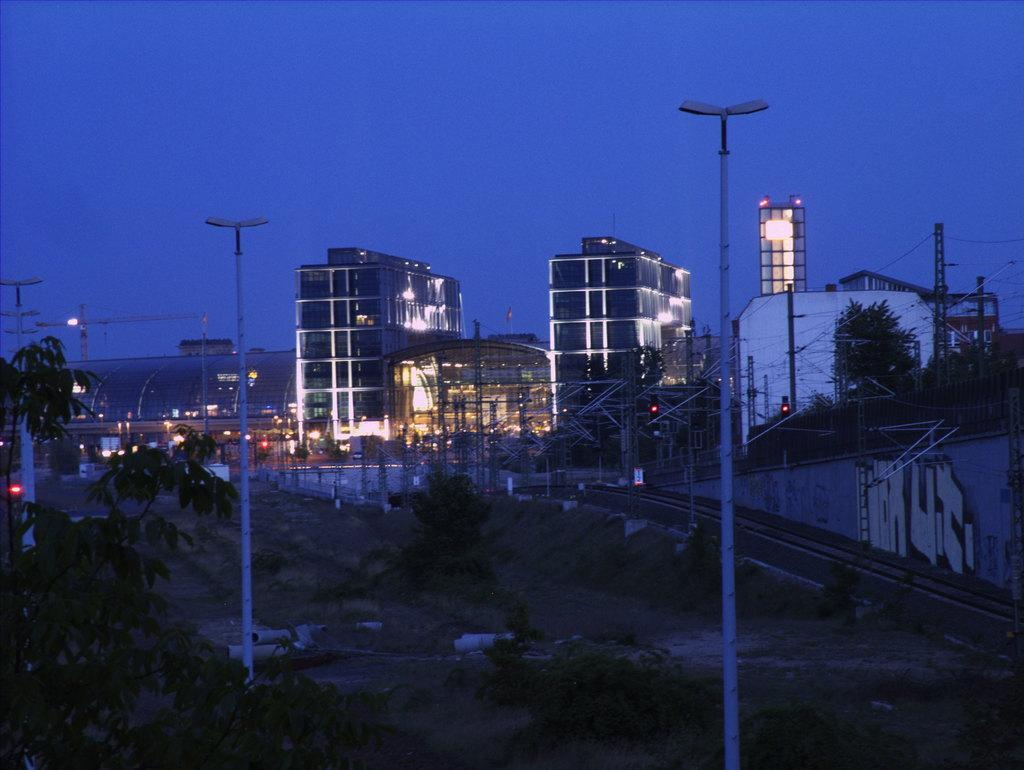What type of structures can be seen in the image? There are buildings and sheds in the image. What is located at the bottom of the image? A: Trees are present at the bottom of the image. What other objects can be seen in the image besides buildings and sheds? Poles and wires are visible in the image. What is on the right side of the image? There is a wall on the right side of the image. What can be seen in the background of the image? The sky is visible in the background of the image. What type of dress is hanging on the fan in the image? There is no fan or dress present in the image. What color is the marble on the wall in the image? There is no marble present in the image; the wall is not described as being made of marble. 